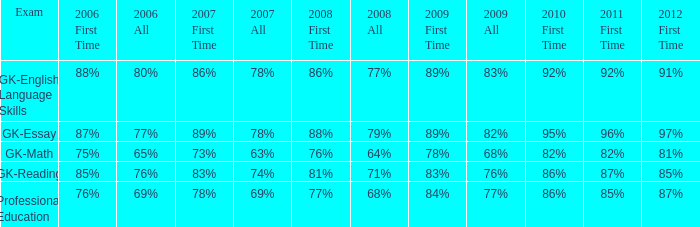What is the rate for 2008 first time when in 2006 it was 85%? 81%. 